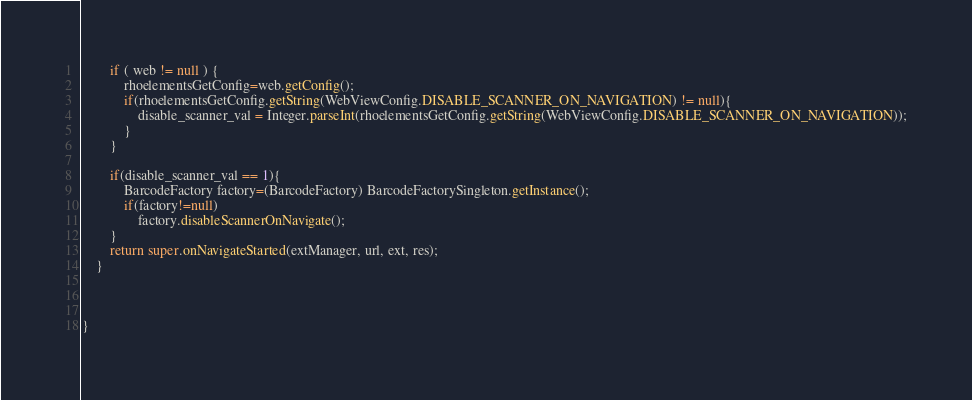<code> <loc_0><loc_0><loc_500><loc_500><_Java_>        if ( web != null ) {
	        rhoelementsGetConfig=web.getConfig();
	        if(rhoelementsGetConfig.getString(WebViewConfig.DISABLE_SCANNER_ON_NAVIGATION) != null){
	        	disable_scanner_val = Integer.parseInt(rhoelementsGetConfig.getString(WebViewConfig.DISABLE_SCANNER_ON_NAVIGATION));
	        }
	    }

		if(disable_scanner_val == 1){
			BarcodeFactory factory=(BarcodeFactory) BarcodeFactorySingleton.getInstance();
			if(factory!=null)
				factory.disableScannerOnNavigate();
		}
		return super.onNavigateStarted(extManager, url, ext, res);
	}


	
}
</code> 